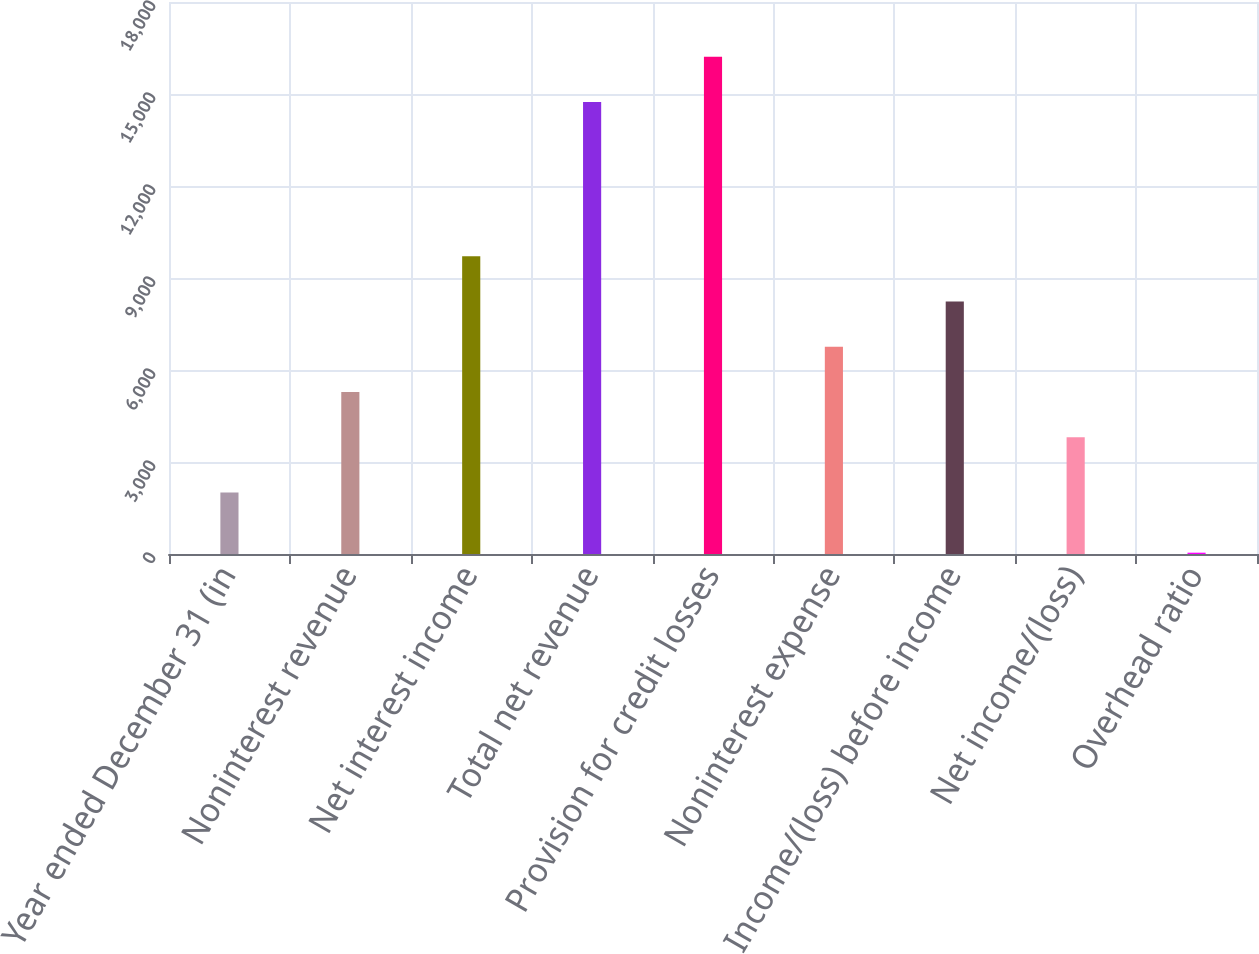<chart> <loc_0><loc_0><loc_500><loc_500><bar_chart><fcel>Year ended December 31 (in<fcel>Noninterest revenue<fcel>Net interest income<fcel>Total net revenue<fcel>Provision for credit losses<fcel>Noninterest expense<fcel>Income/(loss) before income<fcel>Net income/(loss)<fcel>Overhead ratio<nl><fcel>2009<fcel>5281.5<fcel>9711<fcel>14742<fcel>16217.5<fcel>6757<fcel>8232.5<fcel>3806<fcel>43<nl></chart> 